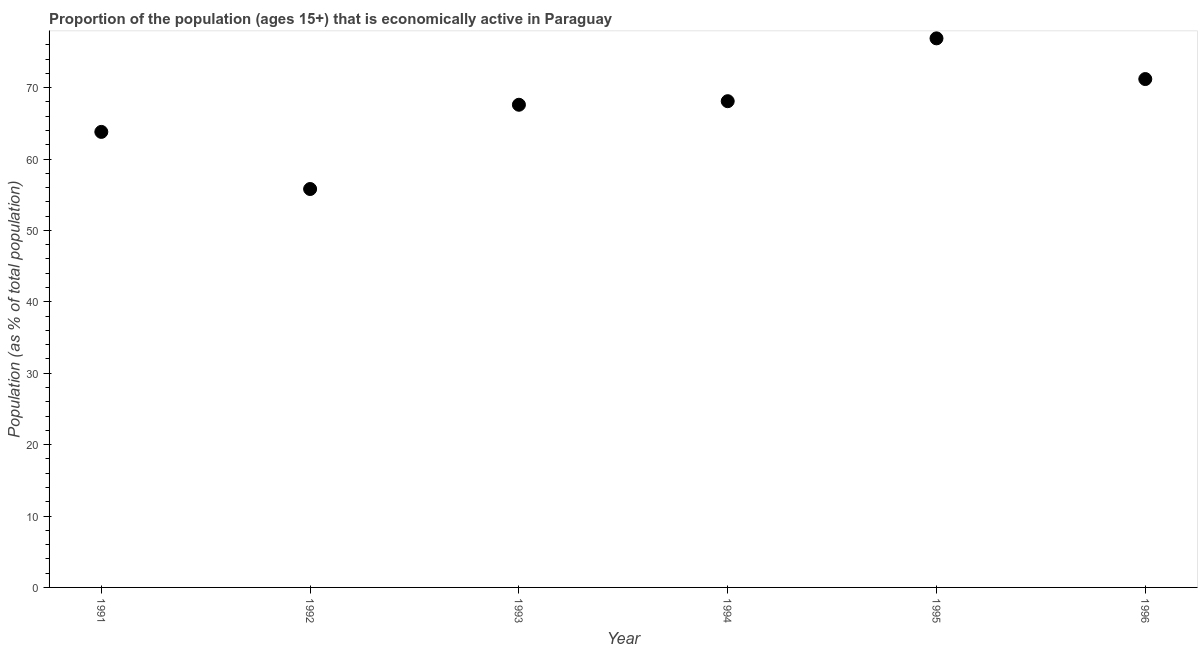What is the percentage of economically active population in 1994?
Provide a short and direct response. 68.1. Across all years, what is the maximum percentage of economically active population?
Provide a short and direct response. 76.9. Across all years, what is the minimum percentage of economically active population?
Your response must be concise. 55.8. In which year was the percentage of economically active population maximum?
Give a very brief answer. 1995. In which year was the percentage of economically active population minimum?
Your answer should be very brief. 1992. What is the sum of the percentage of economically active population?
Your answer should be very brief. 403.4. What is the difference between the percentage of economically active population in 1992 and 1995?
Your answer should be compact. -21.1. What is the average percentage of economically active population per year?
Offer a very short reply. 67.23. What is the median percentage of economically active population?
Give a very brief answer. 67.85. In how many years, is the percentage of economically active population greater than 8 %?
Keep it short and to the point. 6. What is the ratio of the percentage of economically active population in 1994 to that in 1996?
Your response must be concise. 0.96. Is the percentage of economically active population in 1992 less than that in 1993?
Your response must be concise. Yes. Is the difference between the percentage of economically active population in 1991 and 1995 greater than the difference between any two years?
Your answer should be very brief. No. What is the difference between the highest and the second highest percentage of economically active population?
Your response must be concise. 5.7. What is the difference between the highest and the lowest percentage of economically active population?
Make the answer very short. 21.1. How many dotlines are there?
Keep it short and to the point. 1. How many years are there in the graph?
Ensure brevity in your answer.  6. Does the graph contain any zero values?
Give a very brief answer. No. Does the graph contain grids?
Offer a very short reply. No. What is the title of the graph?
Your response must be concise. Proportion of the population (ages 15+) that is economically active in Paraguay. What is the label or title of the Y-axis?
Ensure brevity in your answer.  Population (as % of total population). What is the Population (as % of total population) in 1991?
Your answer should be very brief. 63.8. What is the Population (as % of total population) in 1992?
Ensure brevity in your answer.  55.8. What is the Population (as % of total population) in 1993?
Give a very brief answer. 67.6. What is the Population (as % of total population) in 1994?
Keep it short and to the point. 68.1. What is the Population (as % of total population) in 1995?
Your response must be concise. 76.9. What is the Population (as % of total population) in 1996?
Provide a succinct answer. 71.2. What is the difference between the Population (as % of total population) in 1991 and 1993?
Offer a terse response. -3.8. What is the difference between the Population (as % of total population) in 1991 and 1994?
Ensure brevity in your answer.  -4.3. What is the difference between the Population (as % of total population) in 1991 and 1995?
Make the answer very short. -13.1. What is the difference between the Population (as % of total population) in 1992 and 1995?
Your response must be concise. -21.1. What is the difference between the Population (as % of total population) in 1992 and 1996?
Your answer should be very brief. -15.4. What is the difference between the Population (as % of total population) in 1993 and 1994?
Your answer should be compact. -0.5. What is the difference between the Population (as % of total population) in 1993 and 1995?
Give a very brief answer. -9.3. What is the difference between the Population (as % of total population) in 1994 and 1995?
Give a very brief answer. -8.8. What is the difference between the Population (as % of total population) in 1995 and 1996?
Offer a very short reply. 5.7. What is the ratio of the Population (as % of total population) in 1991 to that in 1992?
Your answer should be compact. 1.14. What is the ratio of the Population (as % of total population) in 1991 to that in 1993?
Make the answer very short. 0.94. What is the ratio of the Population (as % of total population) in 1991 to that in 1994?
Offer a terse response. 0.94. What is the ratio of the Population (as % of total population) in 1991 to that in 1995?
Your answer should be very brief. 0.83. What is the ratio of the Population (as % of total population) in 1991 to that in 1996?
Ensure brevity in your answer.  0.9. What is the ratio of the Population (as % of total population) in 1992 to that in 1993?
Your answer should be compact. 0.82. What is the ratio of the Population (as % of total population) in 1992 to that in 1994?
Your response must be concise. 0.82. What is the ratio of the Population (as % of total population) in 1992 to that in 1995?
Ensure brevity in your answer.  0.73. What is the ratio of the Population (as % of total population) in 1992 to that in 1996?
Offer a very short reply. 0.78. What is the ratio of the Population (as % of total population) in 1993 to that in 1994?
Give a very brief answer. 0.99. What is the ratio of the Population (as % of total population) in 1993 to that in 1995?
Give a very brief answer. 0.88. What is the ratio of the Population (as % of total population) in 1993 to that in 1996?
Offer a very short reply. 0.95. What is the ratio of the Population (as % of total population) in 1994 to that in 1995?
Make the answer very short. 0.89. What is the ratio of the Population (as % of total population) in 1994 to that in 1996?
Offer a very short reply. 0.96. 